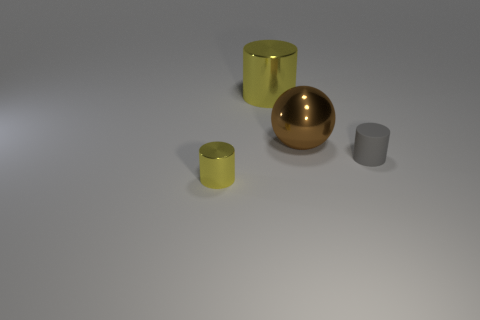What might be the purpose of these objects? These objects could be purely decorative, intended to display the attractive qualities of the materials and the simplicity of geometric shapes. Alternatively, if functional, the cylinders could be containers or holders, while the sphere might serve as a sleek paperweight or a decorative orb. 